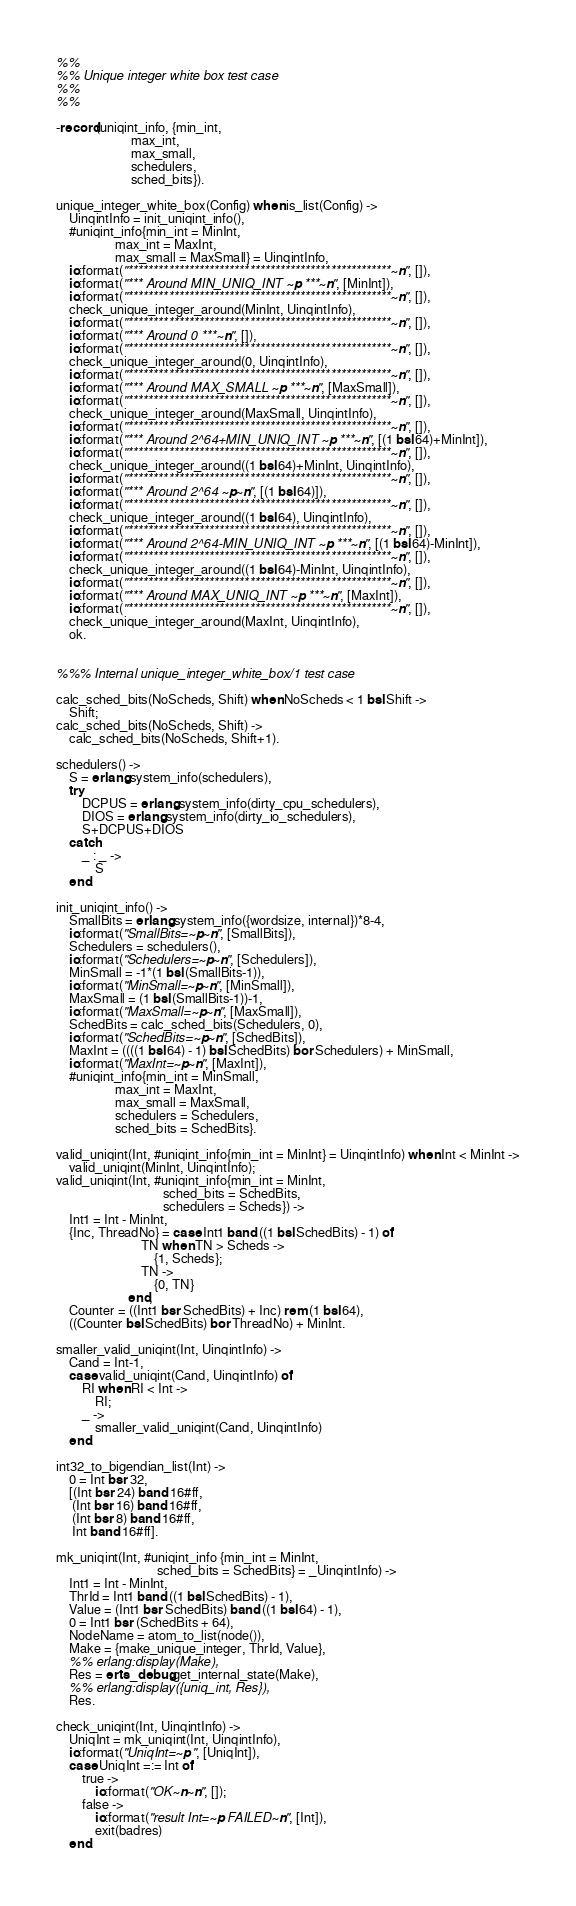Convert code to text. <code><loc_0><loc_0><loc_500><loc_500><_Erlang_>%%
%% Unique integer white box test case
%%
%%

-record(uniqint_info, {min_int,
                       max_int,
                       max_small,
                       schedulers,
                       sched_bits}).

unique_integer_white_box(Config) when is_list(Config) ->
    UinqintInfo = init_uniqint_info(),
    #uniqint_info{min_int = MinInt,
                  max_int = MaxInt,
                  max_small = MaxSmall} = UinqintInfo,
    io:format("****************************************************~n", []),
    io:format("*** Around MIN_UNIQ_INT ~p ***~n", [MinInt]),
    io:format("****************************************************~n", []),
    check_unique_integer_around(MinInt, UinqintInfo),
    io:format("****************************************************~n", []),
    io:format("*** Around 0 ***~n", []),
    io:format("****************************************************~n", []),
    check_unique_integer_around(0, UinqintInfo),
    io:format("****************************************************~n", []),
    io:format("*** Around MAX_SMALL ~p ***~n", [MaxSmall]),
    io:format("****************************************************~n", []),
    check_unique_integer_around(MaxSmall, UinqintInfo),
    io:format("****************************************************~n", []),
    io:format("*** Around 2^64+MIN_UNIQ_INT ~p ***~n", [(1 bsl 64)+MinInt]),
    io:format("****************************************************~n", []),
    check_unique_integer_around((1 bsl 64)+MinInt, UinqintInfo),
    io:format("****************************************************~n", []),
    io:format("*** Around 2^64 ~p~n", [(1 bsl 64)]),
    io:format("****************************************************~n", []),
    check_unique_integer_around((1 bsl 64), UinqintInfo),
    io:format("****************************************************~n", []),
    io:format("*** Around 2^64-MIN_UNIQ_INT ~p ***~n", [(1 bsl 64)-MinInt]),
    io:format("****************************************************~n", []),
    check_unique_integer_around((1 bsl 64)-MinInt, UinqintInfo),
    io:format("****************************************************~n", []),
    io:format("*** Around MAX_UNIQ_INT ~p ***~n", [MaxInt]),
    io:format("****************************************************~n", []),
    check_unique_integer_around(MaxInt, UinqintInfo),
    ok.


%%% Internal unique_integer_white_box/1 test case

calc_sched_bits(NoScheds, Shift) when NoScheds < 1 bsl Shift ->
    Shift;
calc_sched_bits(NoScheds, Shift) ->
    calc_sched_bits(NoScheds, Shift+1).

schedulers() ->
    S = erlang:system_info(schedulers),
    try
        DCPUS = erlang:system_info(dirty_cpu_schedulers),
        DIOS = erlang:system_info(dirty_io_schedulers),
        S+DCPUS+DIOS
    catch
        _ : _ ->
            S
    end.

init_uniqint_info() ->
    SmallBits = erlang:system_info({wordsize, internal})*8-4,
    io:format("SmallBits=~p~n", [SmallBits]),
    Schedulers = schedulers(),
    io:format("Schedulers=~p~n", [Schedulers]),
    MinSmall = -1*(1 bsl (SmallBits-1)),
    io:format("MinSmall=~p~n", [MinSmall]),
    MaxSmall = (1 bsl (SmallBits-1))-1,
    io:format("MaxSmall=~p~n", [MaxSmall]),
    SchedBits = calc_sched_bits(Schedulers, 0),
    io:format("SchedBits=~p~n", [SchedBits]),
    MaxInt = ((((1 bsl 64) - 1) bsl SchedBits) bor Schedulers) + MinSmall,
    io:format("MaxInt=~p~n", [MaxInt]),
    #uniqint_info{min_int = MinSmall,
                  max_int = MaxInt,
                  max_small = MaxSmall,
                  schedulers = Schedulers,
                  sched_bits = SchedBits}.

valid_uniqint(Int, #uniqint_info{min_int = MinInt} = UinqintInfo) when Int < MinInt ->
    valid_uniqint(MinInt, UinqintInfo);
valid_uniqint(Int, #uniqint_info{min_int = MinInt,
                                 sched_bits = SchedBits,
                                 schedulers = Scheds}) ->
    Int1 = Int - MinInt,
    {Inc, ThreadNo} = case Int1 band ((1 bsl SchedBits) - 1) of
                          TN when TN > Scheds ->
                              {1, Scheds};
                          TN ->
                              {0, TN}
                      end,
    Counter = ((Int1 bsr SchedBits) + Inc) rem (1 bsl 64),
    ((Counter bsl SchedBits) bor ThreadNo) + MinInt.

smaller_valid_uniqint(Int, UinqintInfo) ->
    Cand = Int-1,
    case valid_uniqint(Cand, UinqintInfo) of
        RI when RI < Int ->
            RI;
        _ ->
            smaller_valid_uniqint(Cand, UinqintInfo)
    end.

int32_to_bigendian_list(Int) ->
    0 = Int bsr 32,
    [(Int bsr 24) band 16#ff,
     (Int bsr 16) band 16#ff,
     (Int bsr 8) band 16#ff,
     Int band 16#ff].

mk_uniqint(Int, #uniqint_info {min_int = MinInt,
                               sched_bits = SchedBits} = _UinqintInfo) ->
    Int1 = Int - MinInt,
    ThrId = Int1 band ((1 bsl SchedBits) - 1),
    Value = (Int1 bsr SchedBits) band ((1 bsl 64) - 1),
    0 = Int1 bsr (SchedBits + 64),
    NodeName = atom_to_list(node()),
    Make = {make_unique_integer, ThrId, Value},
    %% erlang:display(Make),
    Res = erts_debug:get_internal_state(Make),
    %% erlang:display({uniq_int, Res}),
    Res.

check_uniqint(Int, UinqintInfo) ->
    UniqInt = mk_uniqint(Int, UinqintInfo),
    io:format("UniqInt=~p ", [UniqInt]),
    case UniqInt =:= Int of
        true ->
            io:format("OK~n~n", []);
        false ->
            io:format("result Int=~p FAILED~n", [Int]),
            exit(badres)
    end.
</code> 